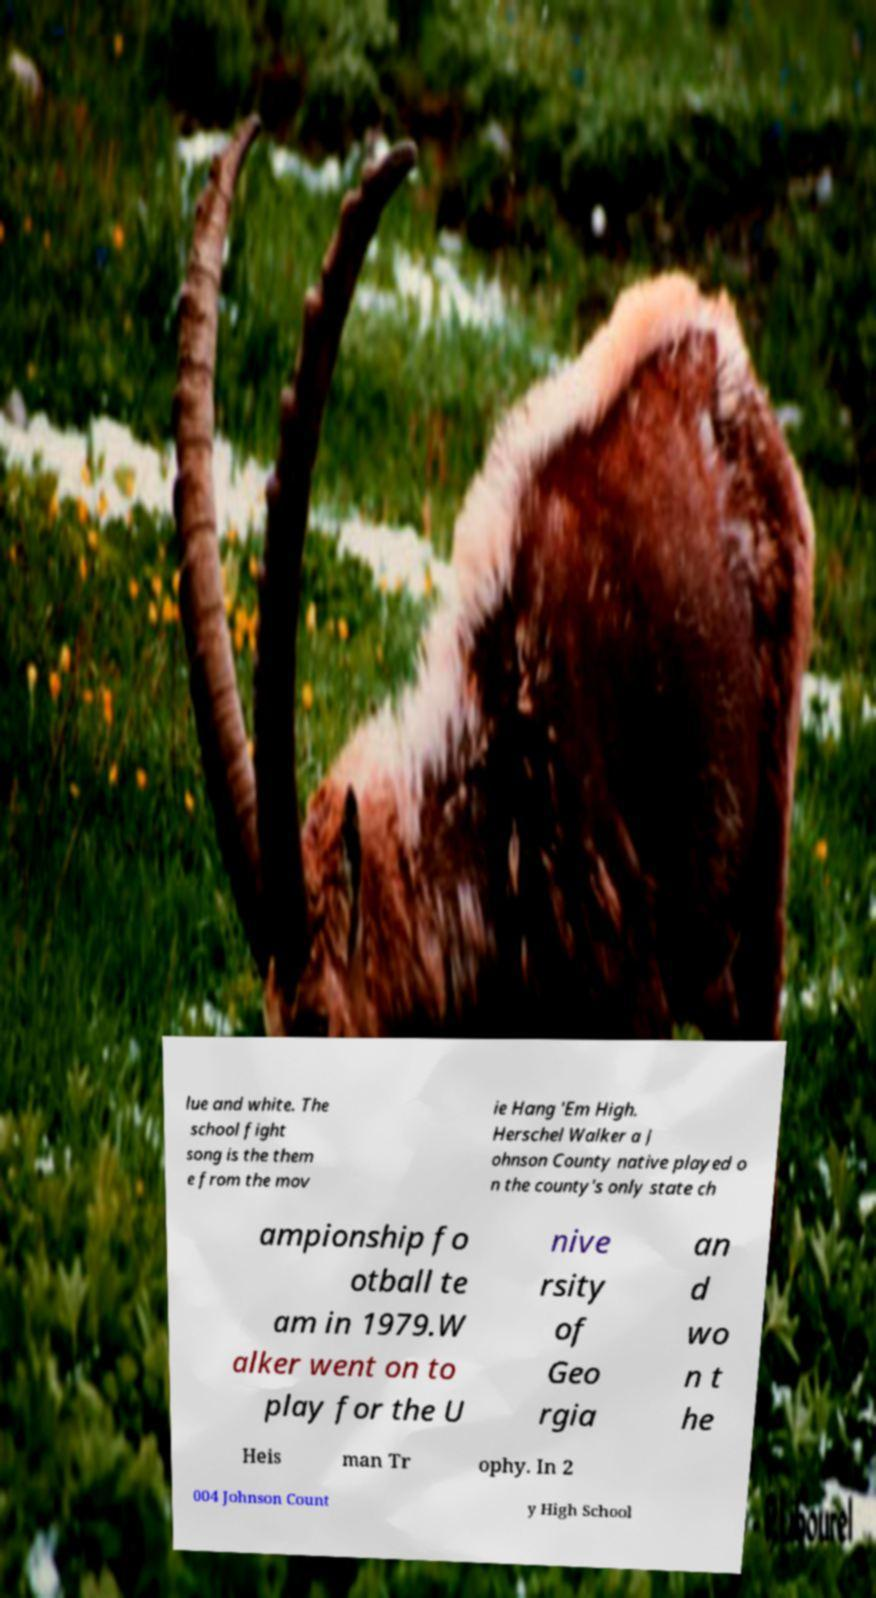Could you extract and type out the text from this image? lue and white. The school fight song is the them e from the mov ie Hang 'Em High. Herschel Walker a J ohnson County native played o n the county's only state ch ampionship fo otball te am in 1979.W alker went on to play for the U nive rsity of Geo rgia an d wo n t he Heis man Tr ophy. In 2 004 Johnson Count y High School 